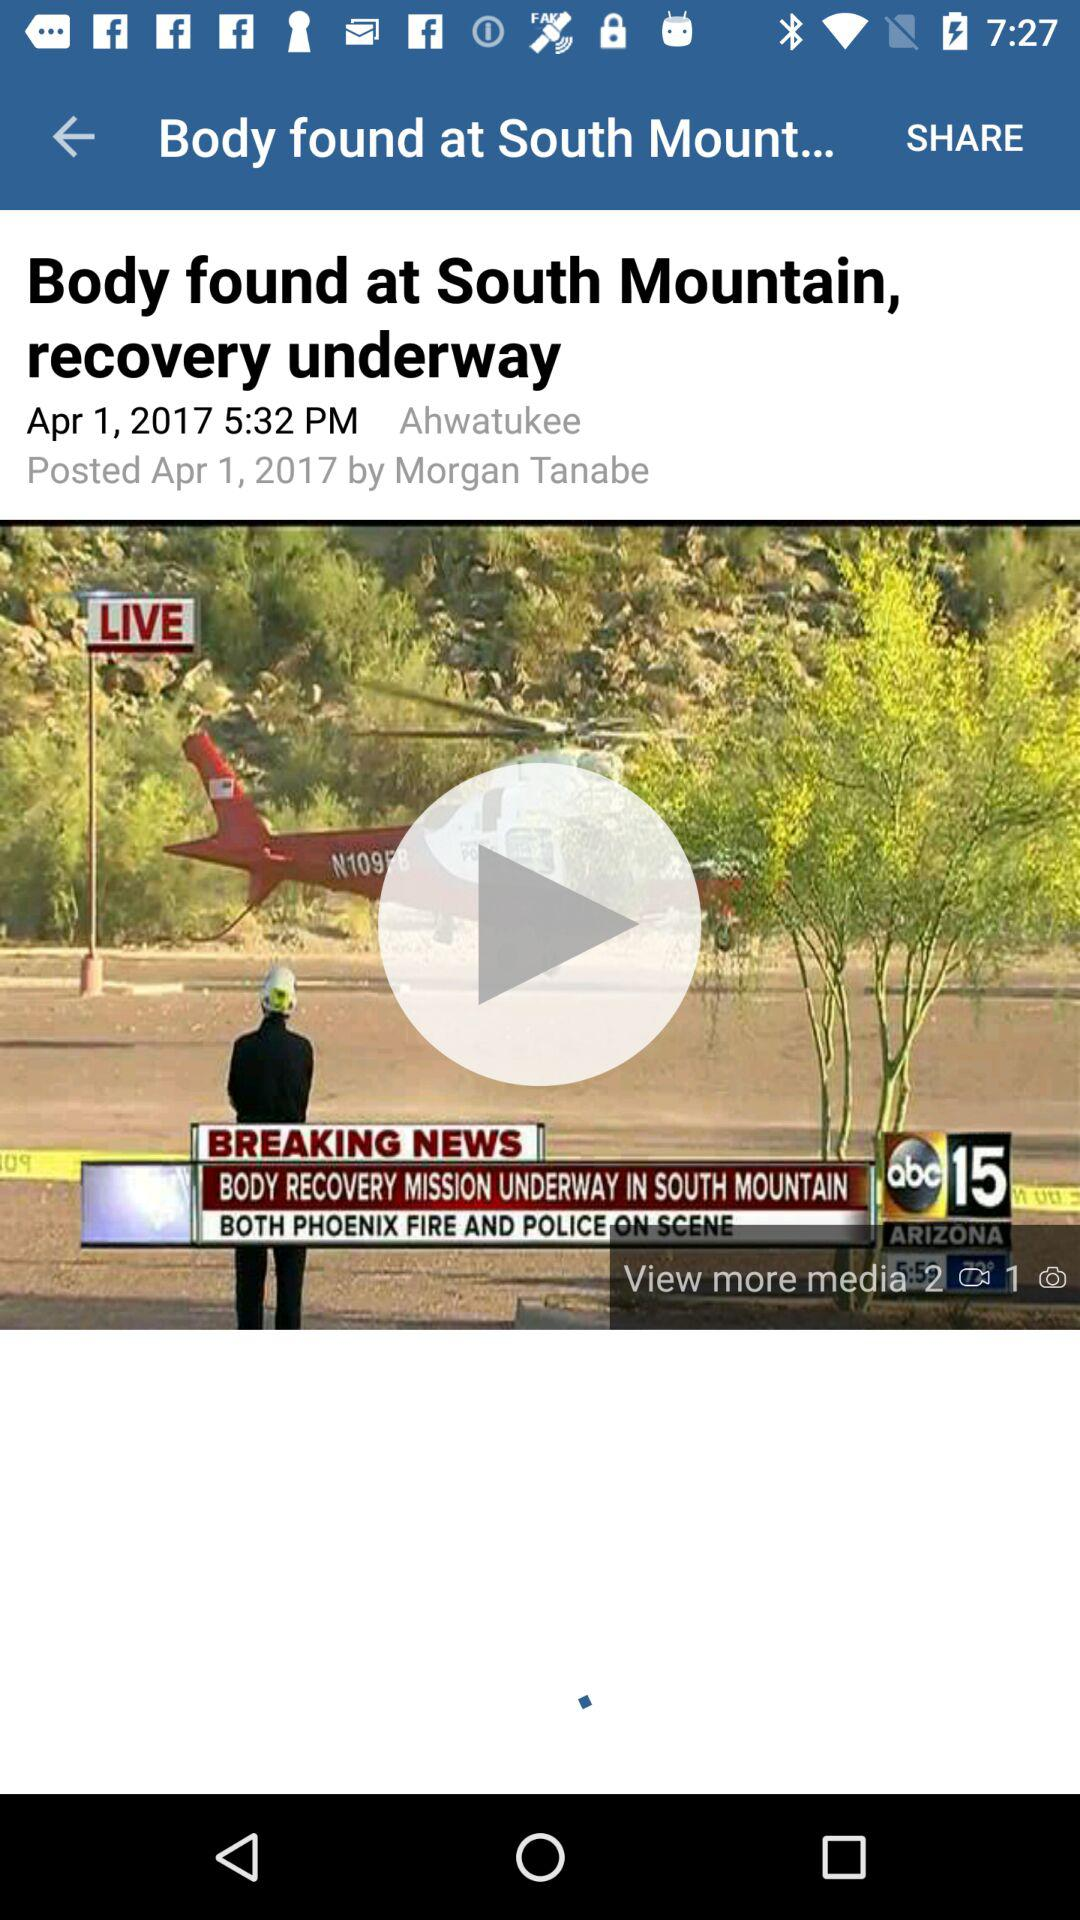When was the news posted? The news was posted on April 1, 2017. 